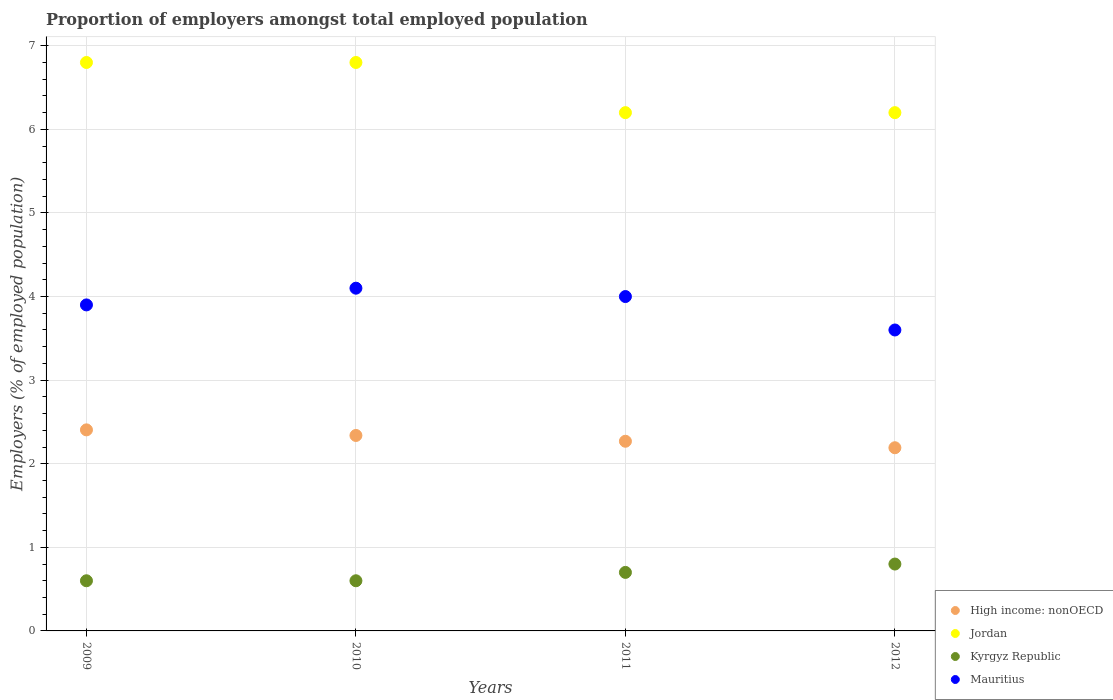What is the proportion of employers in Mauritius in 2009?
Ensure brevity in your answer.  3.9. Across all years, what is the maximum proportion of employers in Jordan?
Give a very brief answer. 6.8. Across all years, what is the minimum proportion of employers in High income: nonOECD?
Keep it short and to the point. 2.19. In which year was the proportion of employers in Jordan maximum?
Provide a succinct answer. 2009. In which year was the proportion of employers in High income: nonOECD minimum?
Give a very brief answer. 2012. What is the difference between the proportion of employers in Kyrgyz Republic in 2009 and that in 2011?
Your answer should be very brief. -0.1. What is the difference between the proportion of employers in High income: nonOECD in 2011 and the proportion of employers in Mauritius in 2010?
Keep it short and to the point. -1.83. What is the average proportion of employers in High income: nonOECD per year?
Offer a very short reply. 2.3. In the year 2009, what is the difference between the proportion of employers in Kyrgyz Republic and proportion of employers in Jordan?
Keep it short and to the point. -6.2. In how many years, is the proportion of employers in Kyrgyz Republic greater than 5.4 %?
Keep it short and to the point. 0. What is the ratio of the proportion of employers in Mauritius in 2010 to that in 2012?
Ensure brevity in your answer.  1.14. Is the proportion of employers in Mauritius in 2010 less than that in 2011?
Offer a very short reply. No. Is the difference between the proportion of employers in Kyrgyz Republic in 2009 and 2011 greater than the difference between the proportion of employers in Jordan in 2009 and 2011?
Ensure brevity in your answer.  No. What is the difference between the highest and the second highest proportion of employers in Kyrgyz Republic?
Keep it short and to the point. 0.1. What is the difference between the highest and the lowest proportion of employers in Mauritius?
Provide a short and direct response. 0.5. Does the proportion of employers in High income: nonOECD monotonically increase over the years?
Your answer should be very brief. No. Is the proportion of employers in Kyrgyz Republic strictly greater than the proportion of employers in Jordan over the years?
Keep it short and to the point. No. How many years are there in the graph?
Your answer should be very brief. 4. What is the difference between two consecutive major ticks on the Y-axis?
Offer a terse response. 1. Where does the legend appear in the graph?
Ensure brevity in your answer.  Bottom right. How many legend labels are there?
Your answer should be very brief. 4. What is the title of the graph?
Make the answer very short. Proportion of employers amongst total employed population. What is the label or title of the Y-axis?
Ensure brevity in your answer.  Employers (% of employed population). What is the Employers (% of employed population) in High income: nonOECD in 2009?
Ensure brevity in your answer.  2.41. What is the Employers (% of employed population) of Jordan in 2009?
Provide a succinct answer. 6.8. What is the Employers (% of employed population) in Kyrgyz Republic in 2009?
Your response must be concise. 0.6. What is the Employers (% of employed population) of Mauritius in 2009?
Offer a very short reply. 3.9. What is the Employers (% of employed population) in High income: nonOECD in 2010?
Keep it short and to the point. 2.34. What is the Employers (% of employed population) of Jordan in 2010?
Give a very brief answer. 6.8. What is the Employers (% of employed population) in Kyrgyz Republic in 2010?
Offer a terse response. 0.6. What is the Employers (% of employed population) in Mauritius in 2010?
Your answer should be very brief. 4.1. What is the Employers (% of employed population) of High income: nonOECD in 2011?
Offer a very short reply. 2.27. What is the Employers (% of employed population) in Jordan in 2011?
Your answer should be compact. 6.2. What is the Employers (% of employed population) in Kyrgyz Republic in 2011?
Keep it short and to the point. 0.7. What is the Employers (% of employed population) of Mauritius in 2011?
Offer a very short reply. 4. What is the Employers (% of employed population) of High income: nonOECD in 2012?
Give a very brief answer. 2.19. What is the Employers (% of employed population) of Jordan in 2012?
Offer a very short reply. 6.2. What is the Employers (% of employed population) of Kyrgyz Republic in 2012?
Keep it short and to the point. 0.8. What is the Employers (% of employed population) of Mauritius in 2012?
Keep it short and to the point. 3.6. Across all years, what is the maximum Employers (% of employed population) of High income: nonOECD?
Keep it short and to the point. 2.41. Across all years, what is the maximum Employers (% of employed population) in Jordan?
Your answer should be very brief. 6.8. Across all years, what is the maximum Employers (% of employed population) in Kyrgyz Republic?
Ensure brevity in your answer.  0.8. Across all years, what is the maximum Employers (% of employed population) of Mauritius?
Provide a succinct answer. 4.1. Across all years, what is the minimum Employers (% of employed population) of High income: nonOECD?
Offer a very short reply. 2.19. Across all years, what is the minimum Employers (% of employed population) in Jordan?
Your answer should be very brief. 6.2. Across all years, what is the minimum Employers (% of employed population) of Kyrgyz Republic?
Your response must be concise. 0.6. Across all years, what is the minimum Employers (% of employed population) in Mauritius?
Keep it short and to the point. 3.6. What is the total Employers (% of employed population) of High income: nonOECD in the graph?
Offer a very short reply. 9.2. What is the total Employers (% of employed population) in Jordan in the graph?
Provide a succinct answer. 26. What is the difference between the Employers (% of employed population) in High income: nonOECD in 2009 and that in 2010?
Provide a short and direct response. 0.07. What is the difference between the Employers (% of employed population) of Jordan in 2009 and that in 2010?
Make the answer very short. 0. What is the difference between the Employers (% of employed population) of Kyrgyz Republic in 2009 and that in 2010?
Give a very brief answer. 0. What is the difference between the Employers (% of employed population) of High income: nonOECD in 2009 and that in 2011?
Your response must be concise. 0.14. What is the difference between the Employers (% of employed population) of Jordan in 2009 and that in 2011?
Keep it short and to the point. 0.6. What is the difference between the Employers (% of employed population) in Mauritius in 2009 and that in 2011?
Ensure brevity in your answer.  -0.1. What is the difference between the Employers (% of employed population) of High income: nonOECD in 2009 and that in 2012?
Keep it short and to the point. 0.21. What is the difference between the Employers (% of employed population) in Jordan in 2009 and that in 2012?
Your response must be concise. 0.6. What is the difference between the Employers (% of employed population) of Kyrgyz Republic in 2009 and that in 2012?
Keep it short and to the point. -0.2. What is the difference between the Employers (% of employed population) in High income: nonOECD in 2010 and that in 2011?
Your answer should be compact. 0.07. What is the difference between the Employers (% of employed population) in Jordan in 2010 and that in 2011?
Provide a short and direct response. 0.6. What is the difference between the Employers (% of employed population) of Kyrgyz Republic in 2010 and that in 2011?
Your answer should be compact. -0.1. What is the difference between the Employers (% of employed population) in High income: nonOECD in 2010 and that in 2012?
Keep it short and to the point. 0.15. What is the difference between the Employers (% of employed population) in Mauritius in 2010 and that in 2012?
Your answer should be compact. 0.5. What is the difference between the Employers (% of employed population) in High income: nonOECD in 2011 and that in 2012?
Give a very brief answer. 0.08. What is the difference between the Employers (% of employed population) of High income: nonOECD in 2009 and the Employers (% of employed population) of Jordan in 2010?
Provide a succinct answer. -4.39. What is the difference between the Employers (% of employed population) in High income: nonOECD in 2009 and the Employers (% of employed population) in Kyrgyz Republic in 2010?
Your answer should be very brief. 1.81. What is the difference between the Employers (% of employed population) in High income: nonOECD in 2009 and the Employers (% of employed population) in Mauritius in 2010?
Your answer should be compact. -1.69. What is the difference between the Employers (% of employed population) of Kyrgyz Republic in 2009 and the Employers (% of employed population) of Mauritius in 2010?
Provide a short and direct response. -3.5. What is the difference between the Employers (% of employed population) of High income: nonOECD in 2009 and the Employers (% of employed population) of Jordan in 2011?
Your response must be concise. -3.79. What is the difference between the Employers (% of employed population) of High income: nonOECD in 2009 and the Employers (% of employed population) of Kyrgyz Republic in 2011?
Your response must be concise. 1.71. What is the difference between the Employers (% of employed population) in High income: nonOECD in 2009 and the Employers (% of employed population) in Mauritius in 2011?
Offer a terse response. -1.59. What is the difference between the Employers (% of employed population) in Jordan in 2009 and the Employers (% of employed population) in Mauritius in 2011?
Give a very brief answer. 2.8. What is the difference between the Employers (% of employed population) in High income: nonOECD in 2009 and the Employers (% of employed population) in Jordan in 2012?
Provide a short and direct response. -3.79. What is the difference between the Employers (% of employed population) of High income: nonOECD in 2009 and the Employers (% of employed population) of Kyrgyz Republic in 2012?
Give a very brief answer. 1.61. What is the difference between the Employers (% of employed population) of High income: nonOECD in 2009 and the Employers (% of employed population) of Mauritius in 2012?
Give a very brief answer. -1.19. What is the difference between the Employers (% of employed population) in High income: nonOECD in 2010 and the Employers (% of employed population) in Jordan in 2011?
Provide a short and direct response. -3.86. What is the difference between the Employers (% of employed population) in High income: nonOECD in 2010 and the Employers (% of employed population) in Kyrgyz Republic in 2011?
Make the answer very short. 1.64. What is the difference between the Employers (% of employed population) of High income: nonOECD in 2010 and the Employers (% of employed population) of Mauritius in 2011?
Offer a terse response. -1.66. What is the difference between the Employers (% of employed population) of Jordan in 2010 and the Employers (% of employed population) of Kyrgyz Republic in 2011?
Offer a terse response. 6.1. What is the difference between the Employers (% of employed population) in Jordan in 2010 and the Employers (% of employed population) in Mauritius in 2011?
Provide a short and direct response. 2.8. What is the difference between the Employers (% of employed population) in High income: nonOECD in 2010 and the Employers (% of employed population) in Jordan in 2012?
Offer a terse response. -3.86. What is the difference between the Employers (% of employed population) in High income: nonOECD in 2010 and the Employers (% of employed population) in Kyrgyz Republic in 2012?
Make the answer very short. 1.54. What is the difference between the Employers (% of employed population) of High income: nonOECD in 2010 and the Employers (% of employed population) of Mauritius in 2012?
Your response must be concise. -1.26. What is the difference between the Employers (% of employed population) in Jordan in 2010 and the Employers (% of employed population) in Mauritius in 2012?
Your response must be concise. 3.2. What is the difference between the Employers (% of employed population) in High income: nonOECD in 2011 and the Employers (% of employed population) in Jordan in 2012?
Give a very brief answer. -3.93. What is the difference between the Employers (% of employed population) of High income: nonOECD in 2011 and the Employers (% of employed population) of Kyrgyz Republic in 2012?
Ensure brevity in your answer.  1.47. What is the difference between the Employers (% of employed population) of High income: nonOECD in 2011 and the Employers (% of employed population) of Mauritius in 2012?
Offer a very short reply. -1.33. What is the difference between the Employers (% of employed population) of Jordan in 2011 and the Employers (% of employed population) of Kyrgyz Republic in 2012?
Provide a succinct answer. 5.4. What is the difference between the Employers (% of employed population) in Jordan in 2011 and the Employers (% of employed population) in Mauritius in 2012?
Ensure brevity in your answer.  2.6. What is the average Employers (% of employed population) in High income: nonOECD per year?
Provide a succinct answer. 2.3. What is the average Employers (% of employed population) of Kyrgyz Republic per year?
Give a very brief answer. 0.68. What is the average Employers (% of employed population) in Mauritius per year?
Your response must be concise. 3.9. In the year 2009, what is the difference between the Employers (% of employed population) of High income: nonOECD and Employers (% of employed population) of Jordan?
Provide a short and direct response. -4.39. In the year 2009, what is the difference between the Employers (% of employed population) of High income: nonOECD and Employers (% of employed population) of Kyrgyz Republic?
Keep it short and to the point. 1.81. In the year 2009, what is the difference between the Employers (% of employed population) in High income: nonOECD and Employers (% of employed population) in Mauritius?
Give a very brief answer. -1.49. In the year 2010, what is the difference between the Employers (% of employed population) of High income: nonOECD and Employers (% of employed population) of Jordan?
Offer a terse response. -4.46. In the year 2010, what is the difference between the Employers (% of employed population) of High income: nonOECD and Employers (% of employed population) of Kyrgyz Republic?
Offer a very short reply. 1.74. In the year 2010, what is the difference between the Employers (% of employed population) of High income: nonOECD and Employers (% of employed population) of Mauritius?
Provide a succinct answer. -1.76. In the year 2010, what is the difference between the Employers (% of employed population) in Jordan and Employers (% of employed population) in Mauritius?
Ensure brevity in your answer.  2.7. In the year 2010, what is the difference between the Employers (% of employed population) of Kyrgyz Republic and Employers (% of employed population) of Mauritius?
Offer a terse response. -3.5. In the year 2011, what is the difference between the Employers (% of employed population) of High income: nonOECD and Employers (% of employed population) of Jordan?
Give a very brief answer. -3.93. In the year 2011, what is the difference between the Employers (% of employed population) in High income: nonOECD and Employers (% of employed population) in Kyrgyz Republic?
Your answer should be compact. 1.57. In the year 2011, what is the difference between the Employers (% of employed population) in High income: nonOECD and Employers (% of employed population) in Mauritius?
Your answer should be compact. -1.73. In the year 2011, what is the difference between the Employers (% of employed population) in Jordan and Employers (% of employed population) in Kyrgyz Republic?
Offer a terse response. 5.5. In the year 2011, what is the difference between the Employers (% of employed population) in Jordan and Employers (% of employed population) in Mauritius?
Offer a very short reply. 2.2. In the year 2011, what is the difference between the Employers (% of employed population) in Kyrgyz Republic and Employers (% of employed population) in Mauritius?
Offer a very short reply. -3.3. In the year 2012, what is the difference between the Employers (% of employed population) in High income: nonOECD and Employers (% of employed population) in Jordan?
Offer a very short reply. -4.01. In the year 2012, what is the difference between the Employers (% of employed population) of High income: nonOECD and Employers (% of employed population) of Kyrgyz Republic?
Provide a short and direct response. 1.39. In the year 2012, what is the difference between the Employers (% of employed population) in High income: nonOECD and Employers (% of employed population) in Mauritius?
Offer a very short reply. -1.41. In the year 2012, what is the difference between the Employers (% of employed population) of Jordan and Employers (% of employed population) of Kyrgyz Republic?
Keep it short and to the point. 5.4. In the year 2012, what is the difference between the Employers (% of employed population) in Jordan and Employers (% of employed population) in Mauritius?
Your answer should be very brief. 2.6. What is the ratio of the Employers (% of employed population) in High income: nonOECD in 2009 to that in 2010?
Offer a terse response. 1.03. What is the ratio of the Employers (% of employed population) of Jordan in 2009 to that in 2010?
Make the answer very short. 1. What is the ratio of the Employers (% of employed population) of Kyrgyz Republic in 2009 to that in 2010?
Offer a very short reply. 1. What is the ratio of the Employers (% of employed population) of Mauritius in 2009 to that in 2010?
Make the answer very short. 0.95. What is the ratio of the Employers (% of employed population) in High income: nonOECD in 2009 to that in 2011?
Keep it short and to the point. 1.06. What is the ratio of the Employers (% of employed population) of Jordan in 2009 to that in 2011?
Your answer should be very brief. 1.1. What is the ratio of the Employers (% of employed population) in Kyrgyz Republic in 2009 to that in 2011?
Ensure brevity in your answer.  0.86. What is the ratio of the Employers (% of employed population) of High income: nonOECD in 2009 to that in 2012?
Provide a short and direct response. 1.1. What is the ratio of the Employers (% of employed population) in Jordan in 2009 to that in 2012?
Provide a short and direct response. 1.1. What is the ratio of the Employers (% of employed population) of Kyrgyz Republic in 2009 to that in 2012?
Make the answer very short. 0.75. What is the ratio of the Employers (% of employed population) of High income: nonOECD in 2010 to that in 2011?
Your response must be concise. 1.03. What is the ratio of the Employers (% of employed population) of Jordan in 2010 to that in 2011?
Your answer should be compact. 1.1. What is the ratio of the Employers (% of employed population) in Kyrgyz Republic in 2010 to that in 2011?
Provide a succinct answer. 0.86. What is the ratio of the Employers (% of employed population) of High income: nonOECD in 2010 to that in 2012?
Your answer should be compact. 1.07. What is the ratio of the Employers (% of employed population) in Jordan in 2010 to that in 2012?
Give a very brief answer. 1.1. What is the ratio of the Employers (% of employed population) of Mauritius in 2010 to that in 2012?
Ensure brevity in your answer.  1.14. What is the ratio of the Employers (% of employed population) in High income: nonOECD in 2011 to that in 2012?
Give a very brief answer. 1.04. What is the ratio of the Employers (% of employed population) of Kyrgyz Republic in 2011 to that in 2012?
Your answer should be very brief. 0.88. What is the ratio of the Employers (% of employed population) of Mauritius in 2011 to that in 2012?
Offer a terse response. 1.11. What is the difference between the highest and the second highest Employers (% of employed population) in High income: nonOECD?
Offer a very short reply. 0.07. What is the difference between the highest and the second highest Employers (% of employed population) in Jordan?
Offer a terse response. 0. What is the difference between the highest and the lowest Employers (% of employed population) of High income: nonOECD?
Ensure brevity in your answer.  0.21. What is the difference between the highest and the lowest Employers (% of employed population) of Kyrgyz Republic?
Your response must be concise. 0.2. 